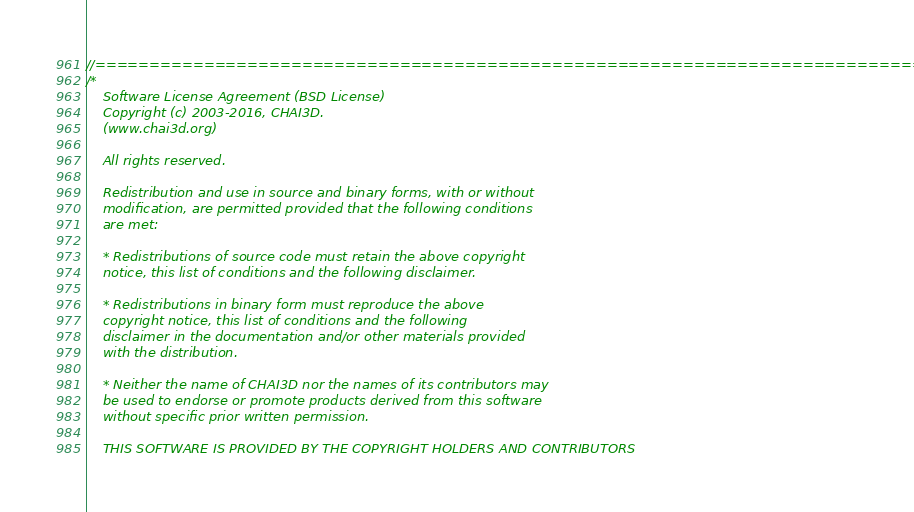Convert code to text. <code><loc_0><loc_0><loc_500><loc_500><_C++_>//==============================================================================
/*
    Software License Agreement (BSD License)
    Copyright (c) 2003-2016, CHAI3D.
    (www.chai3d.org)

    All rights reserved.

    Redistribution and use in source and binary forms, with or without
    modification, are permitted provided that the following conditions
    are met:

    * Redistributions of source code must retain the above copyright
    notice, this list of conditions and the following disclaimer.

    * Redistributions in binary form must reproduce the above
    copyright notice, this list of conditions and the following
    disclaimer in the documentation and/or other materials provided
    with the distribution.

    * Neither the name of CHAI3D nor the names of its contributors may
    be used to endorse or promote products derived from this software
    without specific prior written permission.

    THIS SOFTWARE IS PROVIDED BY THE COPYRIGHT HOLDERS AND CONTRIBUTORS</code> 